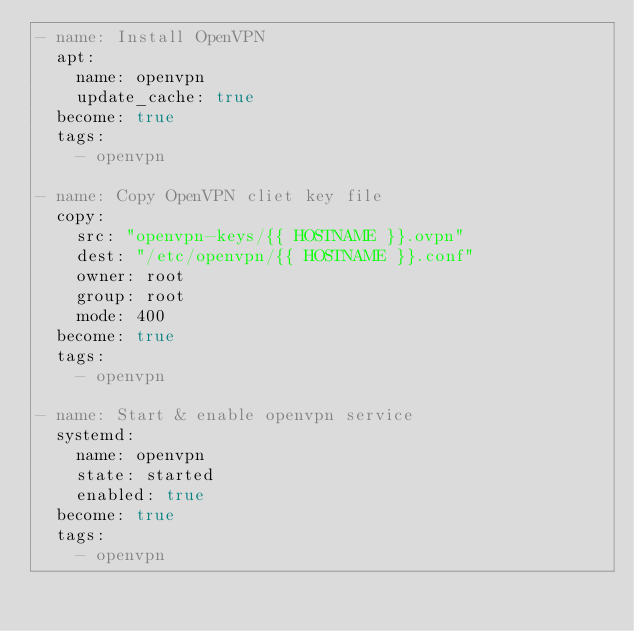Convert code to text. <code><loc_0><loc_0><loc_500><loc_500><_YAML_>- name: Install OpenVPN
  apt:
    name: openvpn
    update_cache: true
  become: true
  tags:
    - openvpn

- name: Copy OpenVPN cliet key file
  copy:
    src: "openvpn-keys/{{ HOSTNAME }}.ovpn"
    dest: "/etc/openvpn/{{ HOSTNAME }}.conf"
    owner: root
    group: root
    mode: 400
  become: true
  tags:
    - openvpn

- name: Start & enable openvpn service
  systemd:
    name: openvpn
    state: started
    enabled: true
  become: true
  tags:
    - openvpn
</code> 